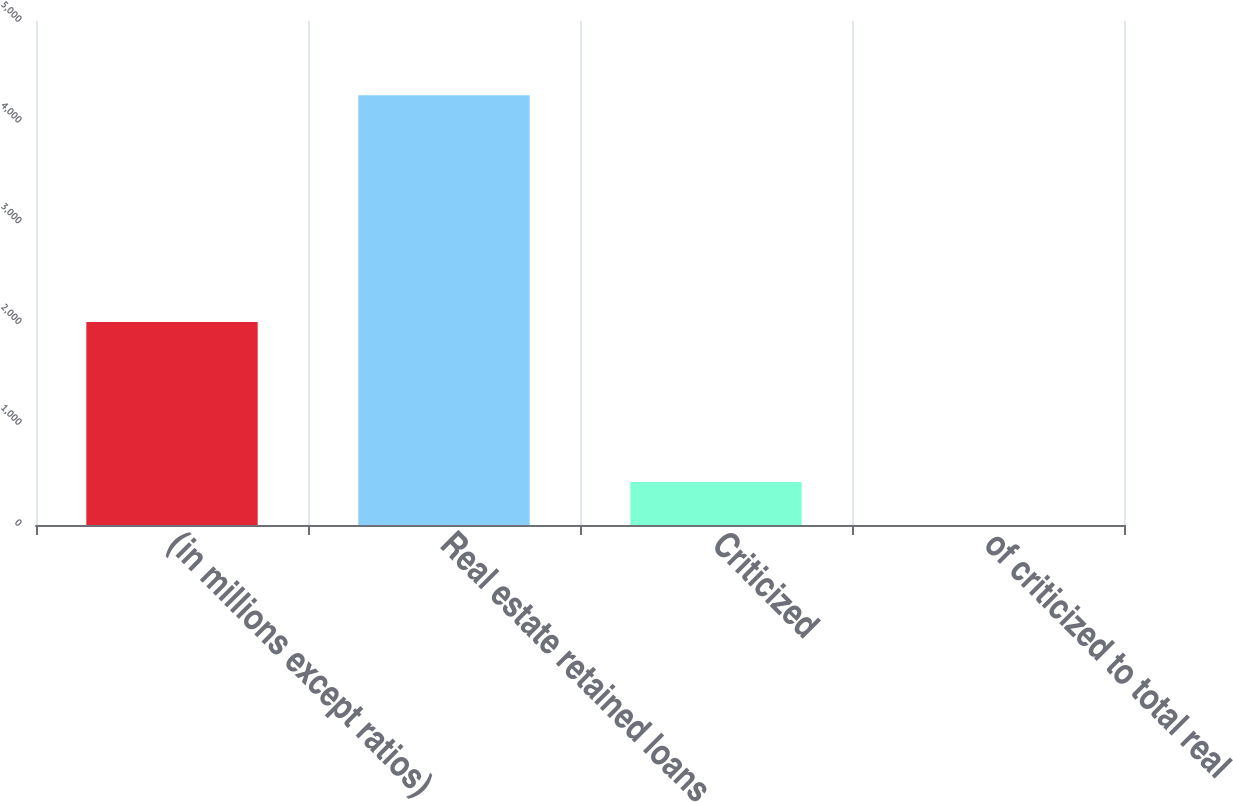Convert chart. <chart><loc_0><loc_0><loc_500><loc_500><bar_chart><fcel>(in millions except ratios)<fcel>Real estate retained loans<fcel>Criticized<fcel>of criticized to total real<nl><fcel>2014<fcel>4264<fcel>427.28<fcel>0.98<nl></chart> 